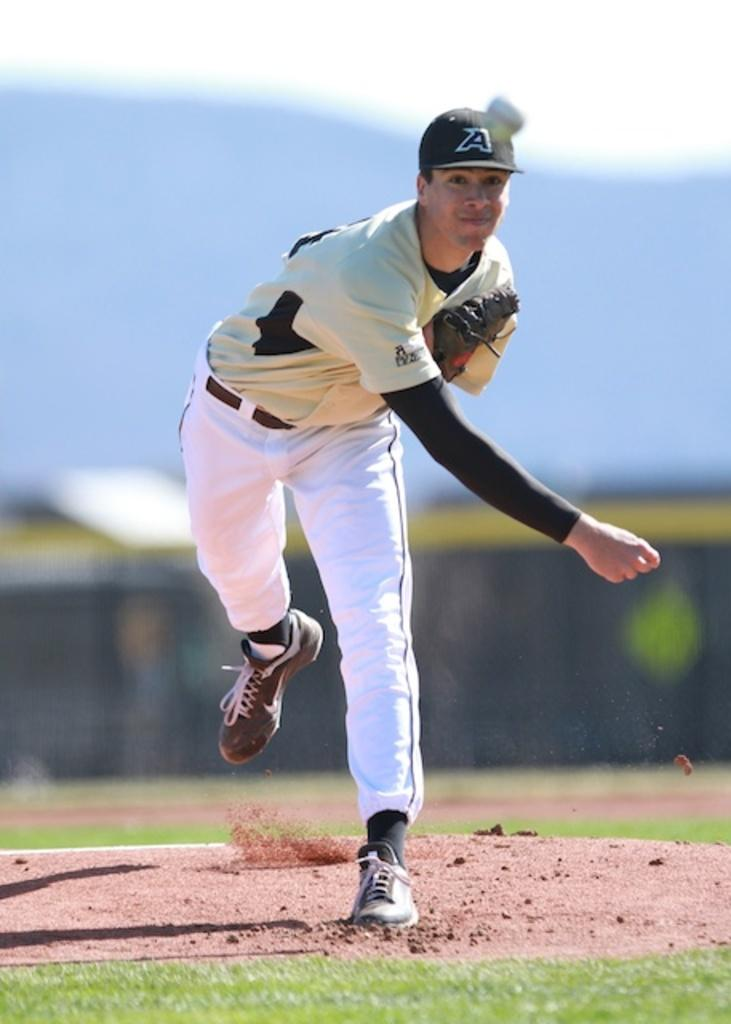<image>
Create a compact narrative representing the image presented. A baseball pitcher has the letter A on his hat, and he is throwing a ball. 